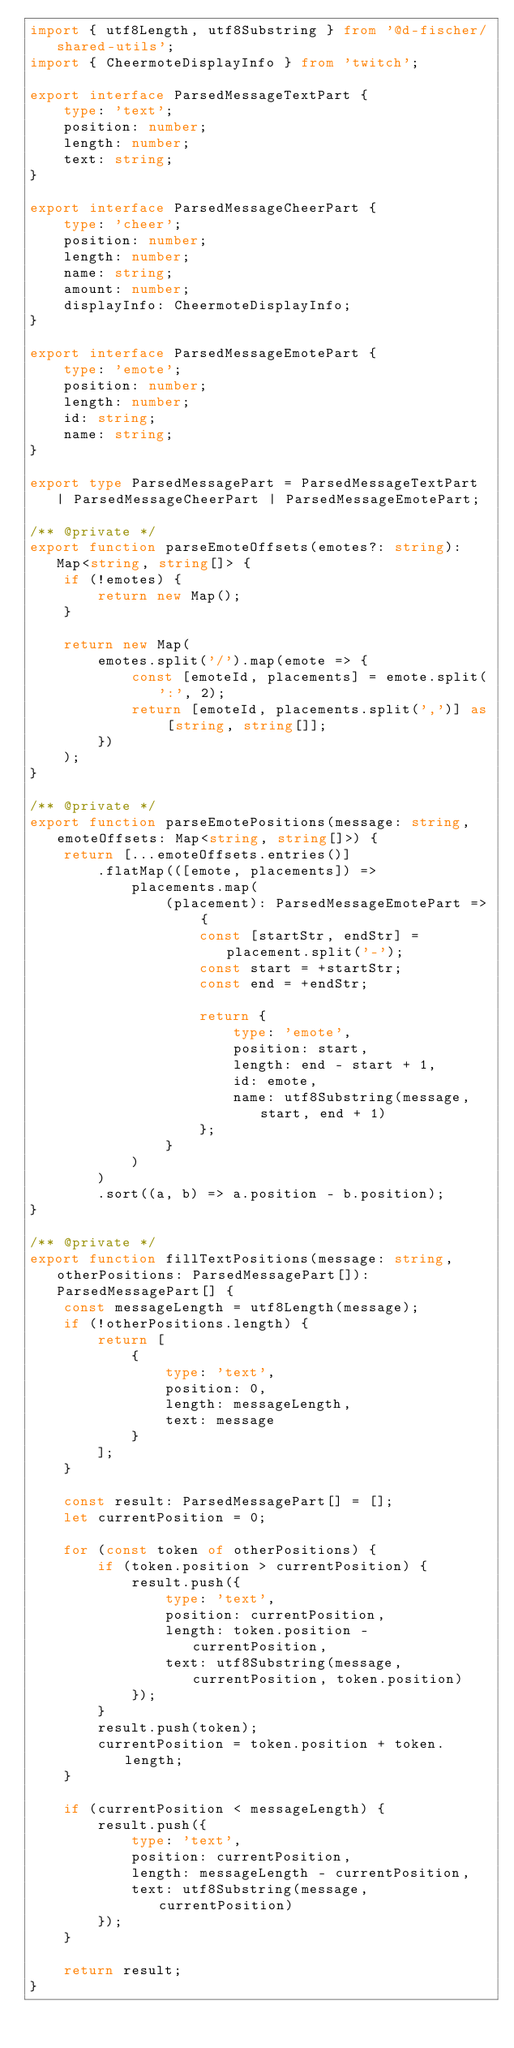Convert code to text. <code><loc_0><loc_0><loc_500><loc_500><_TypeScript_>import { utf8Length, utf8Substring } from '@d-fischer/shared-utils';
import { CheermoteDisplayInfo } from 'twitch';

export interface ParsedMessageTextPart {
	type: 'text';
	position: number;
	length: number;
	text: string;
}

export interface ParsedMessageCheerPart {
	type: 'cheer';
	position: number;
	length: number;
	name: string;
	amount: number;
	displayInfo: CheermoteDisplayInfo;
}

export interface ParsedMessageEmotePart {
	type: 'emote';
	position: number;
	length: number;
	id: string;
	name: string;
}

export type ParsedMessagePart = ParsedMessageTextPart | ParsedMessageCheerPart | ParsedMessageEmotePart;

/** @private */
export function parseEmoteOffsets(emotes?: string): Map<string, string[]> {
	if (!emotes) {
		return new Map();
	}

	return new Map(
		emotes.split('/').map(emote => {
			const [emoteId, placements] = emote.split(':', 2);
			return [emoteId, placements.split(',')] as [string, string[]];
		})
	);
}

/** @private */
export function parseEmotePositions(message: string, emoteOffsets: Map<string, string[]>) {
	return [...emoteOffsets.entries()]
		.flatMap(([emote, placements]) =>
			placements.map(
				(placement): ParsedMessageEmotePart => {
					const [startStr, endStr] = placement.split('-');
					const start = +startStr;
					const end = +endStr;

					return {
						type: 'emote',
						position: start,
						length: end - start + 1,
						id: emote,
						name: utf8Substring(message, start, end + 1)
					};
				}
			)
		)
		.sort((a, b) => a.position - b.position);
}

/** @private */
export function fillTextPositions(message: string, otherPositions: ParsedMessagePart[]): ParsedMessagePart[] {
	const messageLength = utf8Length(message);
	if (!otherPositions.length) {
		return [
			{
				type: 'text',
				position: 0,
				length: messageLength,
				text: message
			}
		];
	}

	const result: ParsedMessagePart[] = [];
	let currentPosition = 0;

	for (const token of otherPositions) {
		if (token.position > currentPosition) {
			result.push({
				type: 'text',
				position: currentPosition,
				length: token.position - currentPosition,
				text: utf8Substring(message, currentPosition, token.position)
			});
		}
		result.push(token);
		currentPosition = token.position + token.length;
	}

	if (currentPosition < messageLength) {
		result.push({
			type: 'text',
			position: currentPosition,
			length: messageLength - currentPosition,
			text: utf8Substring(message, currentPosition)
		});
	}

	return result;
}
</code> 